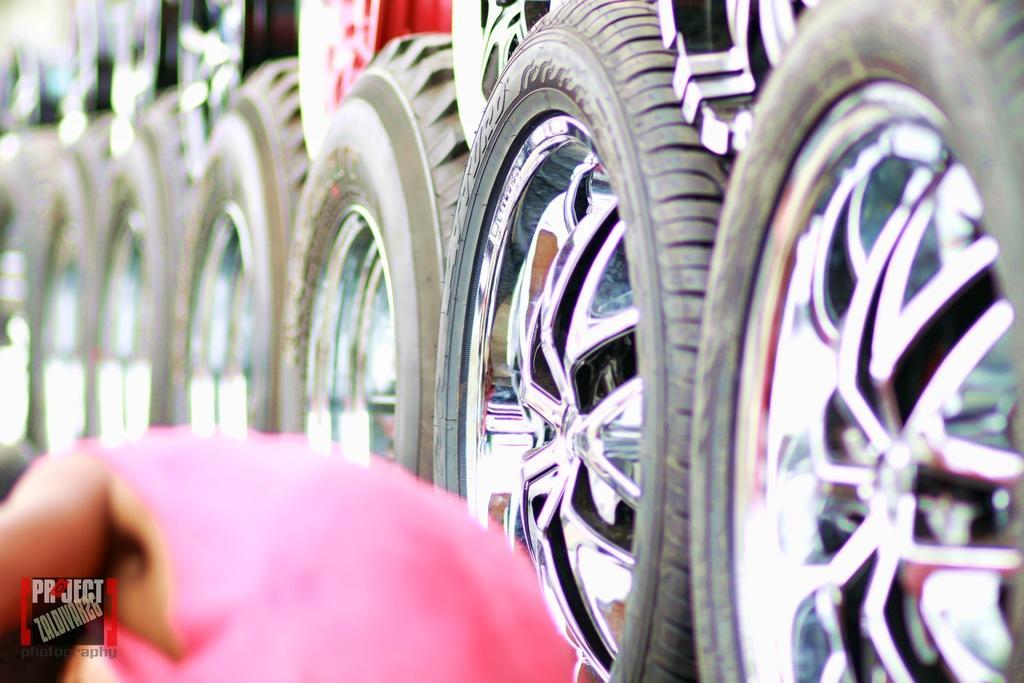Could you give a brief overview of what you see in this image? In this image we can see a person at the bottom and on the right side we can see many tires. 